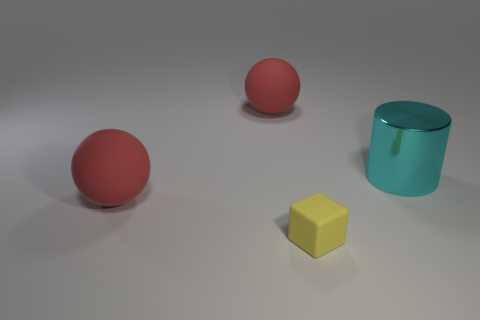Add 4 big metal things. How many objects exist? 8 Subtract all cubes. How many objects are left? 3 Subtract all big red balls. Subtract all large cyan objects. How many objects are left? 1 Add 1 yellow matte objects. How many yellow matte objects are left? 2 Add 1 cyan metallic things. How many cyan metallic things exist? 2 Subtract 0 purple balls. How many objects are left? 4 